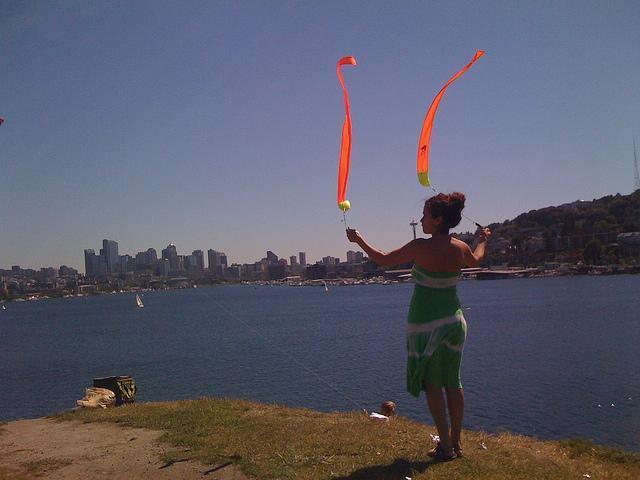How many waves are in the water?
Give a very brief answer. 0. How many people can you see?
Give a very brief answer. 1. How many cows are away from the camera?
Give a very brief answer. 0. 